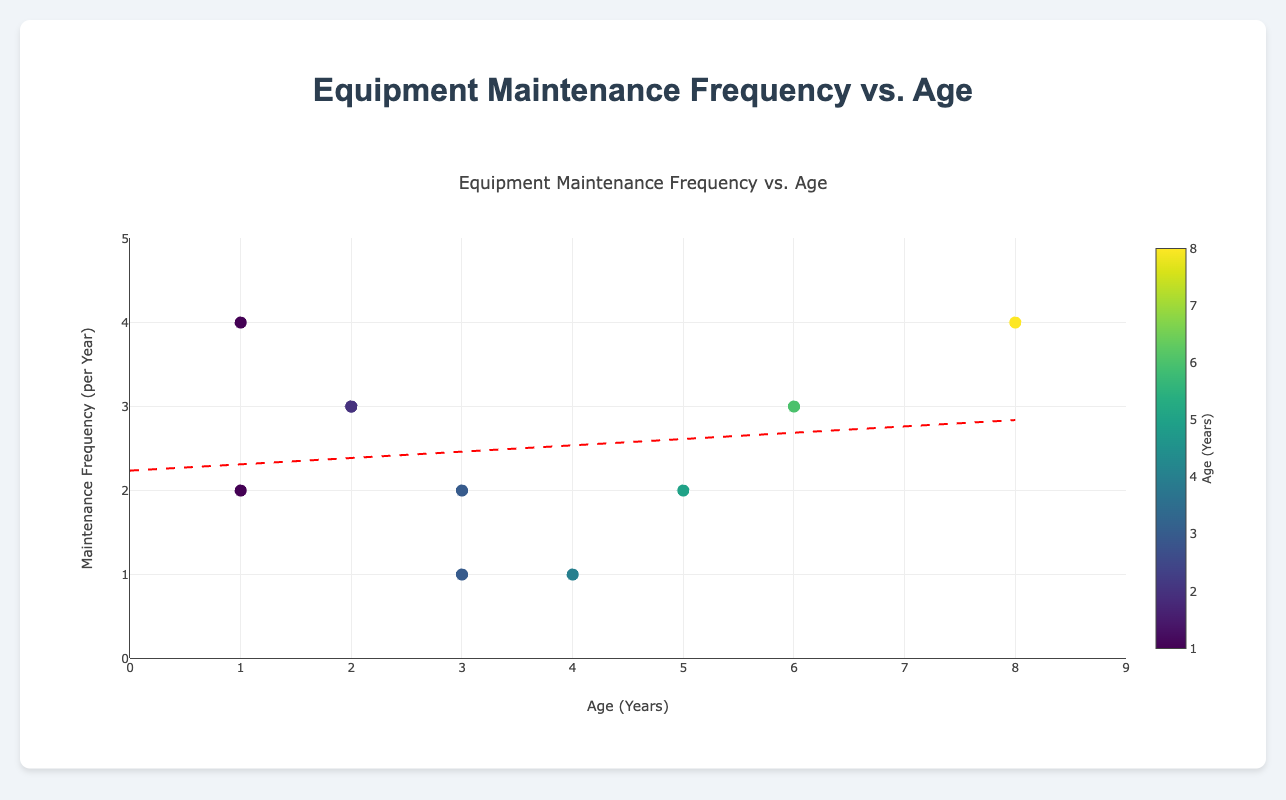How many equipment data points are plotted in the figure? By counting the markers (data points) in the scatter plot representing each piece of equipment, we see there are 10 points.
Answer: 10 What is the title of the figure? The figure's title is displayed prominently at the top and reads "Equipment Maintenance Frequency vs. Age".
Answer: Equipment Maintenance Frequency vs. Age Which equipment is the oldest, and what is its predictive failure date? The oldest equipment is identified by finding the marker with the highest x-axis value (Age in Years). The Backup Generator is the oldest at 8 years, with a predictive failure date of 2023-12-22.
Answer: Backup Generator, 2023-12-22 Is there a trend in maintenance frequency as equipment ages? By examining the trendline added to the plot, we can see whether it slopes upwards, downwards, or remains flat. Here, the trendline slopes slightly upward, indicating that maintenance frequency tends to increase as equipment ages.
Answer: Yes, it tends to increase Which equipment requires the most frequent maintenance, and how old is it? The equipment requiring the most frequent maintenance is identified by finding the marker with the highest y-axis value. The HVAC System has the highest maintenance frequency of 4 times per year and is 1 year old.
Answer: HVAC System, 1 year old What is the range of equipment ages displayed in the figure? The x-axis represents the age in years. The data points range from 1 year (youngest) to 8 years (oldest) on the plot.
Answer: 1 to 8 years By how much does maintenance frequency differ between the HVAC System and the Sprinkler System? The maintenance frequencies for the HVAC System and Sprinkler System are 4 and 1 per year, respectively. The difference in frequency is calculated as 4 - 1.
Answer: 3 Which system has the earliest predictive failure date, and how old is it? The earliest predictive failure date is found by examining the detailed hover information for each marker. The Elevator has the earliest predicted failure date of 2023-08-10 and is 6 years old.
Answer: Elevator, 6 years old What can you infer about the relationship between maintenance frequency and predictive failure dates? By examining the predictive failure dates associated with different maintenance frequencies, we can infer that equipment requiring more frequent maintenance tends to have later predictive failure dates, suggesting that frequent maintenance may extend equipment lifespan.
Answer: More frequent maintenance tends to delay failure Which equipment on the plot has the same maintenance frequency but different ages? By looking at the markers and their labels, the Sound System, Intercom System, and Elevator each have a maintenance frequency of 3 times per year but differ in age (2, 2, and 6 years, respectively).
Answer: Sound System, Intercom System, Elevator 